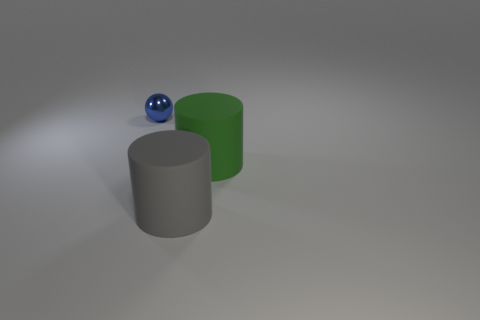Are there fewer gray rubber objects that are on the left side of the metallic thing than small shiny balls?
Keep it short and to the point. Yes. What number of big cylinders are there?
Keep it short and to the point. 2. There is a big gray thing; is its shape the same as the thing on the left side of the large gray thing?
Provide a succinct answer. No. Is the number of small spheres on the right side of the gray matte object less than the number of big green cylinders that are right of the blue metallic sphere?
Make the answer very short. Yes. Are there any other things that are the same shape as the metallic thing?
Ensure brevity in your answer.  No. Is the shape of the green rubber object the same as the small blue metallic thing?
Offer a very short reply. No. Is there anything else that is the same material as the big green object?
Offer a very short reply. Yes. What size is the green object?
Your answer should be very brief. Large. There is a object that is in front of the small metal object and behind the big gray thing; what is its color?
Give a very brief answer. Green. Is the number of tiny blue cylinders greater than the number of blue metal balls?
Offer a terse response. No. 